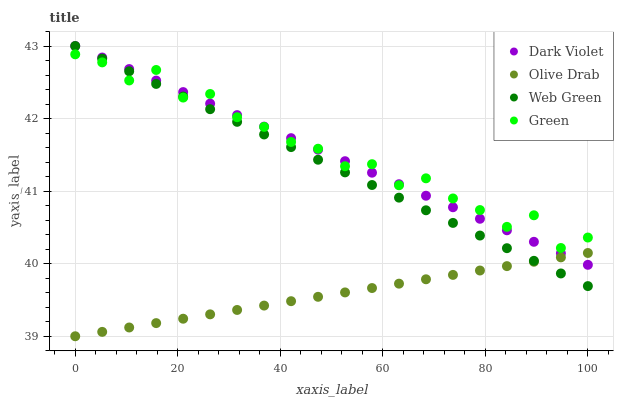Does Olive Drab have the minimum area under the curve?
Answer yes or no. Yes. Does Green have the maximum area under the curve?
Answer yes or no. Yes. Does Green have the minimum area under the curve?
Answer yes or no. No. Does Olive Drab have the maximum area under the curve?
Answer yes or no. No. Is Web Green the smoothest?
Answer yes or no. Yes. Is Green the roughest?
Answer yes or no. Yes. Is Olive Drab the smoothest?
Answer yes or no. No. Is Olive Drab the roughest?
Answer yes or no. No. Does Olive Drab have the lowest value?
Answer yes or no. Yes. Does Green have the lowest value?
Answer yes or no. No. Does Dark Violet have the highest value?
Answer yes or no. Yes. Does Green have the highest value?
Answer yes or no. No. Is Olive Drab less than Green?
Answer yes or no. Yes. Is Green greater than Olive Drab?
Answer yes or no. Yes. Does Dark Violet intersect Green?
Answer yes or no. Yes. Is Dark Violet less than Green?
Answer yes or no. No. Is Dark Violet greater than Green?
Answer yes or no. No. Does Olive Drab intersect Green?
Answer yes or no. No. 